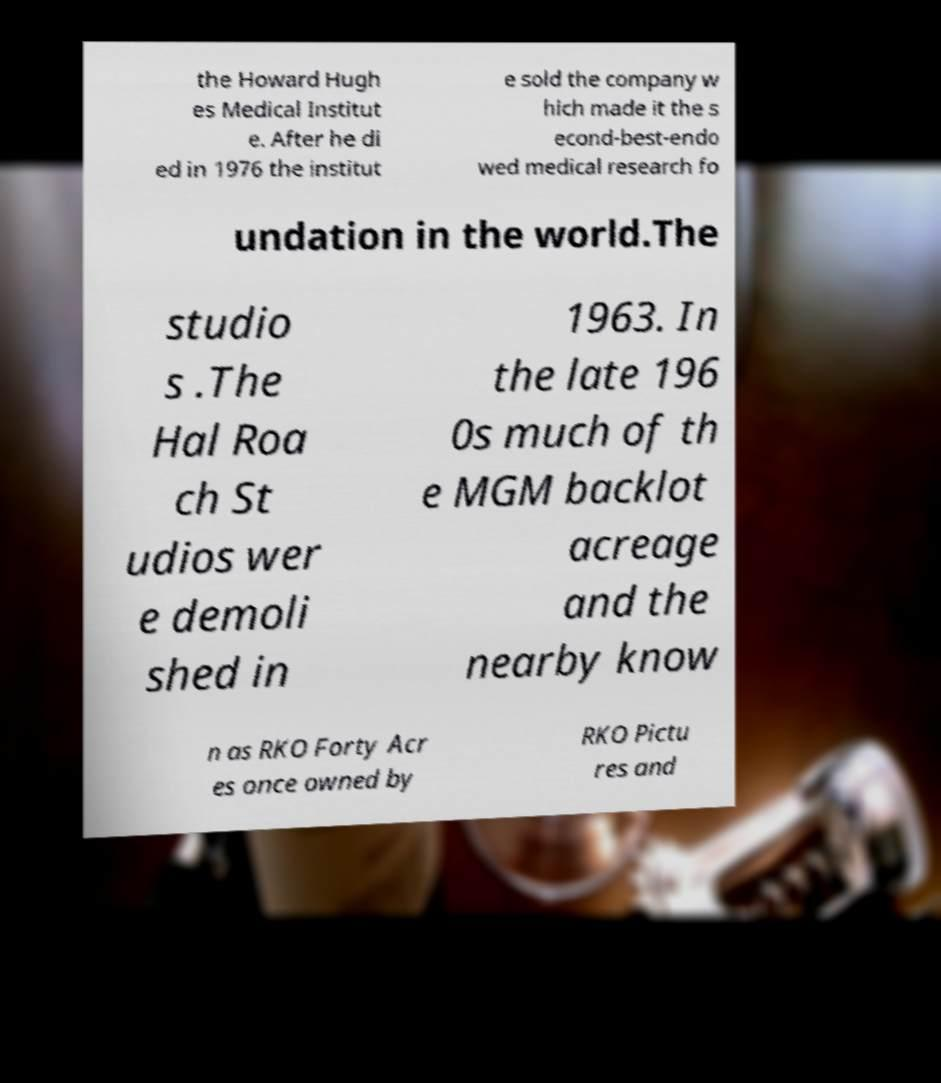What messages or text are displayed in this image? I need them in a readable, typed format. the Howard Hugh es Medical Institut e. After he di ed in 1976 the institut e sold the company w hich made it the s econd-best-endo wed medical research fo undation in the world.The studio s .The Hal Roa ch St udios wer e demoli shed in 1963. In the late 196 0s much of th e MGM backlot acreage and the nearby know n as RKO Forty Acr es once owned by RKO Pictu res and 